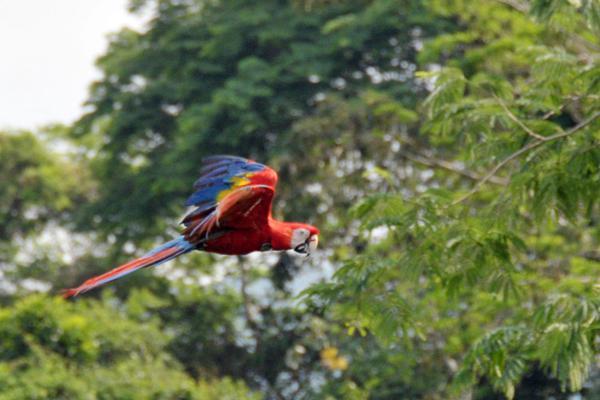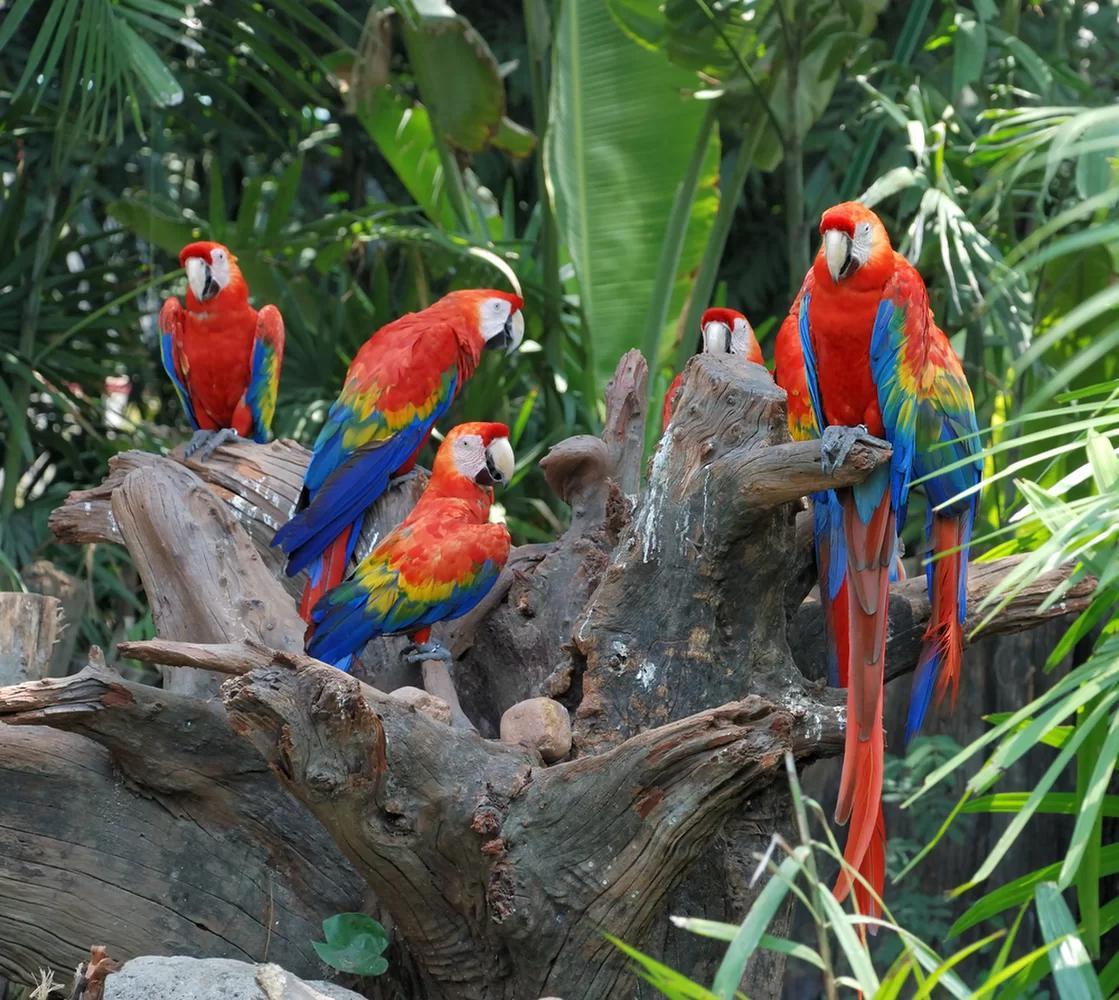The first image is the image on the left, the second image is the image on the right. Assess this claim about the two images: "There is no more than one parrot in the left image.". Correct or not? Answer yes or no. Yes. 